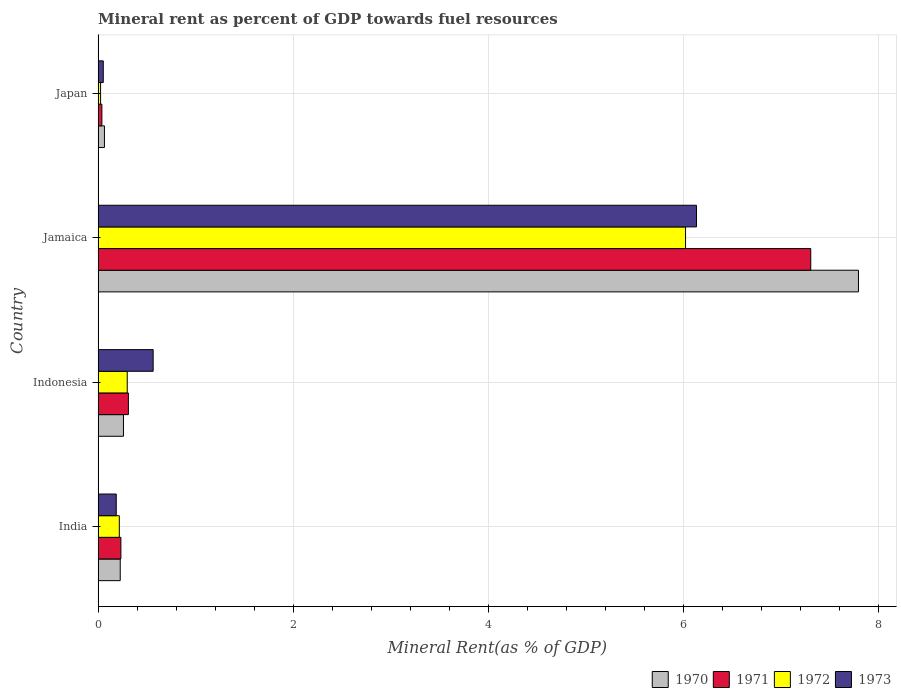How many groups of bars are there?
Your response must be concise. 4. How many bars are there on the 4th tick from the top?
Make the answer very short. 4. How many bars are there on the 2nd tick from the bottom?
Give a very brief answer. 4. In how many cases, is the number of bars for a given country not equal to the number of legend labels?
Keep it short and to the point. 0. What is the mineral rent in 1973 in Japan?
Give a very brief answer. 0.05. Across all countries, what is the maximum mineral rent in 1972?
Give a very brief answer. 6.03. Across all countries, what is the minimum mineral rent in 1971?
Your answer should be very brief. 0.04. In which country was the mineral rent in 1973 maximum?
Offer a terse response. Jamaica. In which country was the mineral rent in 1972 minimum?
Offer a very short reply. Japan. What is the total mineral rent in 1970 in the graph?
Provide a succinct answer. 8.35. What is the difference between the mineral rent in 1972 in Indonesia and that in Japan?
Ensure brevity in your answer.  0.27. What is the difference between the mineral rent in 1973 in India and the mineral rent in 1970 in Indonesia?
Keep it short and to the point. -0.07. What is the average mineral rent in 1970 per country?
Your response must be concise. 2.09. What is the difference between the mineral rent in 1973 and mineral rent in 1972 in Japan?
Offer a very short reply. 0.03. In how many countries, is the mineral rent in 1971 greater than 6.4 %?
Make the answer very short. 1. What is the ratio of the mineral rent in 1970 in India to that in Jamaica?
Provide a short and direct response. 0.03. What is the difference between the highest and the second highest mineral rent in 1970?
Your answer should be compact. 7.54. What is the difference between the highest and the lowest mineral rent in 1971?
Provide a short and direct response. 7.27. Is the sum of the mineral rent in 1973 in India and Indonesia greater than the maximum mineral rent in 1972 across all countries?
Keep it short and to the point. No. Is it the case that in every country, the sum of the mineral rent in 1970 and mineral rent in 1973 is greater than the mineral rent in 1971?
Ensure brevity in your answer.  Yes. How many bars are there?
Your answer should be very brief. 16. Are all the bars in the graph horizontal?
Give a very brief answer. Yes. Does the graph contain any zero values?
Offer a terse response. No. Does the graph contain grids?
Provide a short and direct response. Yes. Where does the legend appear in the graph?
Ensure brevity in your answer.  Bottom right. How many legend labels are there?
Make the answer very short. 4. How are the legend labels stacked?
Make the answer very short. Horizontal. What is the title of the graph?
Your answer should be very brief. Mineral rent as percent of GDP towards fuel resources. What is the label or title of the X-axis?
Make the answer very short. Mineral Rent(as % of GDP). What is the Mineral Rent(as % of GDP) of 1970 in India?
Provide a succinct answer. 0.23. What is the Mineral Rent(as % of GDP) of 1971 in India?
Offer a very short reply. 0.23. What is the Mineral Rent(as % of GDP) in 1972 in India?
Your response must be concise. 0.22. What is the Mineral Rent(as % of GDP) of 1973 in India?
Provide a short and direct response. 0.19. What is the Mineral Rent(as % of GDP) of 1970 in Indonesia?
Your answer should be very brief. 0.26. What is the Mineral Rent(as % of GDP) in 1971 in Indonesia?
Your answer should be compact. 0.31. What is the Mineral Rent(as % of GDP) in 1972 in Indonesia?
Ensure brevity in your answer.  0.3. What is the Mineral Rent(as % of GDP) of 1973 in Indonesia?
Provide a short and direct response. 0.56. What is the Mineral Rent(as % of GDP) in 1970 in Jamaica?
Give a very brief answer. 7.8. What is the Mineral Rent(as % of GDP) of 1971 in Jamaica?
Provide a short and direct response. 7.31. What is the Mineral Rent(as % of GDP) of 1972 in Jamaica?
Make the answer very short. 6.03. What is the Mineral Rent(as % of GDP) of 1973 in Jamaica?
Offer a very short reply. 6.14. What is the Mineral Rent(as % of GDP) in 1970 in Japan?
Make the answer very short. 0.06. What is the Mineral Rent(as % of GDP) in 1971 in Japan?
Provide a short and direct response. 0.04. What is the Mineral Rent(as % of GDP) in 1972 in Japan?
Provide a short and direct response. 0.03. What is the Mineral Rent(as % of GDP) of 1973 in Japan?
Offer a terse response. 0.05. Across all countries, what is the maximum Mineral Rent(as % of GDP) of 1970?
Offer a very short reply. 7.8. Across all countries, what is the maximum Mineral Rent(as % of GDP) in 1971?
Your response must be concise. 7.31. Across all countries, what is the maximum Mineral Rent(as % of GDP) of 1972?
Provide a short and direct response. 6.03. Across all countries, what is the maximum Mineral Rent(as % of GDP) in 1973?
Ensure brevity in your answer.  6.14. Across all countries, what is the minimum Mineral Rent(as % of GDP) in 1970?
Your answer should be compact. 0.06. Across all countries, what is the minimum Mineral Rent(as % of GDP) of 1971?
Provide a succinct answer. 0.04. Across all countries, what is the minimum Mineral Rent(as % of GDP) of 1972?
Give a very brief answer. 0.03. Across all countries, what is the minimum Mineral Rent(as % of GDP) in 1973?
Your response must be concise. 0.05. What is the total Mineral Rent(as % of GDP) in 1970 in the graph?
Make the answer very short. 8.35. What is the total Mineral Rent(as % of GDP) in 1971 in the graph?
Keep it short and to the point. 7.89. What is the total Mineral Rent(as % of GDP) of 1972 in the graph?
Make the answer very short. 6.57. What is the total Mineral Rent(as % of GDP) of 1973 in the graph?
Provide a short and direct response. 6.94. What is the difference between the Mineral Rent(as % of GDP) in 1970 in India and that in Indonesia?
Your response must be concise. -0.03. What is the difference between the Mineral Rent(as % of GDP) in 1971 in India and that in Indonesia?
Your response must be concise. -0.08. What is the difference between the Mineral Rent(as % of GDP) of 1972 in India and that in Indonesia?
Your answer should be very brief. -0.08. What is the difference between the Mineral Rent(as % of GDP) in 1973 in India and that in Indonesia?
Your answer should be compact. -0.38. What is the difference between the Mineral Rent(as % of GDP) in 1970 in India and that in Jamaica?
Provide a succinct answer. -7.57. What is the difference between the Mineral Rent(as % of GDP) of 1971 in India and that in Jamaica?
Your answer should be very brief. -7.08. What is the difference between the Mineral Rent(as % of GDP) of 1972 in India and that in Jamaica?
Keep it short and to the point. -5.81. What is the difference between the Mineral Rent(as % of GDP) of 1973 in India and that in Jamaica?
Provide a short and direct response. -5.95. What is the difference between the Mineral Rent(as % of GDP) in 1970 in India and that in Japan?
Provide a succinct answer. 0.16. What is the difference between the Mineral Rent(as % of GDP) in 1971 in India and that in Japan?
Provide a short and direct response. 0.2. What is the difference between the Mineral Rent(as % of GDP) in 1972 in India and that in Japan?
Your answer should be very brief. 0.19. What is the difference between the Mineral Rent(as % of GDP) in 1973 in India and that in Japan?
Give a very brief answer. 0.13. What is the difference between the Mineral Rent(as % of GDP) of 1970 in Indonesia and that in Jamaica?
Keep it short and to the point. -7.54. What is the difference between the Mineral Rent(as % of GDP) of 1971 in Indonesia and that in Jamaica?
Your response must be concise. -7. What is the difference between the Mineral Rent(as % of GDP) of 1972 in Indonesia and that in Jamaica?
Offer a very short reply. -5.73. What is the difference between the Mineral Rent(as % of GDP) of 1973 in Indonesia and that in Jamaica?
Offer a terse response. -5.57. What is the difference between the Mineral Rent(as % of GDP) of 1970 in Indonesia and that in Japan?
Offer a very short reply. 0.2. What is the difference between the Mineral Rent(as % of GDP) of 1971 in Indonesia and that in Japan?
Provide a succinct answer. 0.27. What is the difference between the Mineral Rent(as % of GDP) in 1972 in Indonesia and that in Japan?
Provide a short and direct response. 0.27. What is the difference between the Mineral Rent(as % of GDP) of 1973 in Indonesia and that in Japan?
Keep it short and to the point. 0.51. What is the difference between the Mineral Rent(as % of GDP) in 1970 in Jamaica and that in Japan?
Keep it short and to the point. 7.73. What is the difference between the Mineral Rent(as % of GDP) of 1971 in Jamaica and that in Japan?
Ensure brevity in your answer.  7.27. What is the difference between the Mineral Rent(as % of GDP) in 1972 in Jamaica and that in Japan?
Provide a succinct answer. 6. What is the difference between the Mineral Rent(as % of GDP) in 1973 in Jamaica and that in Japan?
Your answer should be very brief. 6.08. What is the difference between the Mineral Rent(as % of GDP) in 1970 in India and the Mineral Rent(as % of GDP) in 1971 in Indonesia?
Offer a terse response. -0.08. What is the difference between the Mineral Rent(as % of GDP) of 1970 in India and the Mineral Rent(as % of GDP) of 1972 in Indonesia?
Provide a succinct answer. -0.07. What is the difference between the Mineral Rent(as % of GDP) of 1970 in India and the Mineral Rent(as % of GDP) of 1973 in Indonesia?
Provide a succinct answer. -0.34. What is the difference between the Mineral Rent(as % of GDP) of 1971 in India and the Mineral Rent(as % of GDP) of 1972 in Indonesia?
Provide a succinct answer. -0.07. What is the difference between the Mineral Rent(as % of GDP) in 1971 in India and the Mineral Rent(as % of GDP) in 1973 in Indonesia?
Provide a succinct answer. -0.33. What is the difference between the Mineral Rent(as % of GDP) of 1972 in India and the Mineral Rent(as % of GDP) of 1973 in Indonesia?
Ensure brevity in your answer.  -0.35. What is the difference between the Mineral Rent(as % of GDP) in 1970 in India and the Mineral Rent(as % of GDP) in 1971 in Jamaica?
Keep it short and to the point. -7.08. What is the difference between the Mineral Rent(as % of GDP) of 1970 in India and the Mineral Rent(as % of GDP) of 1972 in Jamaica?
Keep it short and to the point. -5.8. What is the difference between the Mineral Rent(as % of GDP) of 1970 in India and the Mineral Rent(as % of GDP) of 1973 in Jamaica?
Offer a terse response. -5.91. What is the difference between the Mineral Rent(as % of GDP) in 1971 in India and the Mineral Rent(as % of GDP) in 1972 in Jamaica?
Offer a very short reply. -5.79. What is the difference between the Mineral Rent(as % of GDP) in 1971 in India and the Mineral Rent(as % of GDP) in 1973 in Jamaica?
Provide a short and direct response. -5.9. What is the difference between the Mineral Rent(as % of GDP) of 1972 in India and the Mineral Rent(as % of GDP) of 1973 in Jamaica?
Offer a terse response. -5.92. What is the difference between the Mineral Rent(as % of GDP) of 1970 in India and the Mineral Rent(as % of GDP) of 1971 in Japan?
Your answer should be very brief. 0.19. What is the difference between the Mineral Rent(as % of GDP) in 1970 in India and the Mineral Rent(as % of GDP) in 1972 in Japan?
Your answer should be compact. 0.2. What is the difference between the Mineral Rent(as % of GDP) in 1970 in India and the Mineral Rent(as % of GDP) in 1973 in Japan?
Provide a short and direct response. 0.17. What is the difference between the Mineral Rent(as % of GDP) in 1971 in India and the Mineral Rent(as % of GDP) in 1972 in Japan?
Ensure brevity in your answer.  0.21. What is the difference between the Mineral Rent(as % of GDP) in 1971 in India and the Mineral Rent(as % of GDP) in 1973 in Japan?
Ensure brevity in your answer.  0.18. What is the difference between the Mineral Rent(as % of GDP) in 1972 in India and the Mineral Rent(as % of GDP) in 1973 in Japan?
Offer a very short reply. 0.16. What is the difference between the Mineral Rent(as % of GDP) in 1970 in Indonesia and the Mineral Rent(as % of GDP) in 1971 in Jamaica?
Keep it short and to the point. -7.05. What is the difference between the Mineral Rent(as % of GDP) in 1970 in Indonesia and the Mineral Rent(as % of GDP) in 1972 in Jamaica?
Offer a very short reply. -5.77. What is the difference between the Mineral Rent(as % of GDP) in 1970 in Indonesia and the Mineral Rent(as % of GDP) in 1973 in Jamaica?
Provide a succinct answer. -5.88. What is the difference between the Mineral Rent(as % of GDP) in 1971 in Indonesia and the Mineral Rent(as % of GDP) in 1972 in Jamaica?
Offer a very short reply. -5.72. What is the difference between the Mineral Rent(as % of GDP) of 1971 in Indonesia and the Mineral Rent(as % of GDP) of 1973 in Jamaica?
Offer a very short reply. -5.83. What is the difference between the Mineral Rent(as % of GDP) in 1972 in Indonesia and the Mineral Rent(as % of GDP) in 1973 in Jamaica?
Make the answer very short. -5.84. What is the difference between the Mineral Rent(as % of GDP) of 1970 in Indonesia and the Mineral Rent(as % of GDP) of 1971 in Japan?
Your answer should be very brief. 0.22. What is the difference between the Mineral Rent(as % of GDP) of 1970 in Indonesia and the Mineral Rent(as % of GDP) of 1972 in Japan?
Your answer should be very brief. 0.23. What is the difference between the Mineral Rent(as % of GDP) of 1970 in Indonesia and the Mineral Rent(as % of GDP) of 1973 in Japan?
Provide a short and direct response. 0.21. What is the difference between the Mineral Rent(as % of GDP) in 1971 in Indonesia and the Mineral Rent(as % of GDP) in 1972 in Japan?
Give a very brief answer. 0.29. What is the difference between the Mineral Rent(as % of GDP) of 1971 in Indonesia and the Mineral Rent(as % of GDP) of 1973 in Japan?
Offer a very short reply. 0.26. What is the difference between the Mineral Rent(as % of GDP) of 1972 in Indonesia and the Mineral Rent(as % of GDP) of 1973 in Japan?
Ensure brevity in your answer.  0.25. What is the difference between the Mineral Rent(as % of GDP) in 1970 in Jamaica and the Mineral Rent(as % of GDP) in 1971 in Japan?
Your response must be concise. 7.76. What is the difference between the Mineral Rent(as % of GDP) in 1970 in Jamaica and the Mineral Rent(as % of GDP) in 1972 in Japan?
Offer a terse response. 7.77. What is the difference between the Mineral Rent(as % of GDP) of 1970 in Jamaica and the Mineral Rent(as % of GDP) of 1973 in Japan?
Offer a very short reply. 7.75. What is the difference between the Mineral Rent(as % of GDP) of 1971 in Jamaica and the Mineral Rent(as % of GDP) of 1972 in Japan?
Offer a terse response. 7.28. What is the difference between the Mineral Rent(as % of GDP) of 1971 in Jamaica and the Mineral Rent(as % of GDP) of 1973 in Japan?
Offer a terse response. 7.26. What is the difference between the Mineral Rent(as % of GDP) in 1972 in Jamaica and the Mineral Rent(as % of GDP) in 1973 in Japan?
Give a very brief answer. 5.97. What is the average Mineral Rent(as % of GDP) of 1970 per country?
Your answer should be very brief. 2.09. What is the average Mineral Rent(as % of GDP) of 1971 per country?
Keep it short and to the point. 1.97. What is the average Mineral Rent(as % of GDP) in 1972 per country?
Give a very brief answer. 1.64. What is the average Mineral Rent(as % of GDP) in 1973 per country?
Your answer should be compact. 1.74. What is the difference between the Mineral Rent(as % of GDP) in 1970 and Mineral Rent(as % of GDP) in 1971 in India?
Your answer should be compact. -0.01. What is the difference between the Mineral Rent(as % of GDP) of 1970 and Mineral Rent(as % of GDP) of 1972 in India?
Keep it short and to the point. 0.01. What is the difference between the Mineral Rent(as % of GDP) of 1970 and Mineral Rent(as % of GDP) of 1973 in India?
Make the answer very short. 0.04. What is the difference between the Mineral Rent(as % of GDP) in 1971 and Mineral Rent(as % of GDP) in 1972 in India?
Keep it short and to the point. 0.02. What is the difference between the Mineral Rent(as % of GDP) of 1971 and Mineral Rent(as % of GDP) of 1973 in India?
Provide a short and direct response. 0.05. What is the difference between the Mineral Rent(as % of GDP) in 1972 and Mineral Rent(as % of GDP) in 1973 in India?
Offer a very short reply. 0.03. What is the difference between the Mineral Rent(as % of GDP) in 1970 and Mineral Rent(as % of GDP) in 1971 in Indonesia?
Offer a terse response. -0.05. What is the difference between the Mineral Rent(as % of GDP) in 1970 and Mineral Rent(as % of GDP) in 1972 in Indonesia?
Your answer should be compact. -0.04. What is the difference between the Mineral Rent(as % of GDP) of 1970 and Mineral Rent(as % of GDP) of 1973 in Indonesia?
Offer a terse response. -0.3. What is the difference between the Mineral Rent(as % of GDP) of 1971 and Mineral Rent(as % of GDP) of 1972 in Indonesia?
Your answer should be compact. 0.01. What is the difference between the Mineral Rent(as % of GDP) in 1971 and Mineral Rent(as % of GDP) in 1973 in Indonesia?
Keep it short and to the point. -0.25. What is the difference between the Mineral Rent(as % of GDP) in 1972 and Mineral Rent(as % of GDP) in 1973 in Indonesia?
Give a very brief answer. -0.27. What is the difference between the Mineral Rent(as % of GDP) in 1970 and Mineral Rent(as % of GDP) in 1971 in Jamaica?
Keep it short and to the point. 0.49. What is the difference between the Mineral Rent(as % of GDP) of 1970 and Mineral Rent(as % of GDP) of 1972 in Jamaica?
Provide a succinct answer. 1.77. What is the difference between the Mineral Rent(as % of GDP) in 1970 and Mineral Rent(as % of GDP) in 1973 in Jamaica?
Your answer should be compact. 1.66. What is the difference between the Mineral Rent(as % of GDP) of 1971 and Mineral Rent(as % of GDP) of 1972 in Jamaica?
Offer a very short reply. 1.28. What is the difference between the Mineral Rent(as % of GDP) of 1971 and Mineral Rent(as % of GDP) of 1973 in Jamaica?
Your response must be concise. 1.17. What is the difference between the Mineral Rent(as % of GDP) in 1972 and Mineral Rent(as % of GDP) in 1973 in Jamaica?
Ensure brevity in your answer.  -0.11. What is the difference between the Mineral Rent(as % of GDP) of 1970 and Mineral Rent(as % of GDP) of 1971 in Japan?
Provide a succinct answer. 0.03. What is the difference between the Mineral Rent(as % of GDP) of 1970 and Mineral Rent(as % of GDP) of 1972 in Japan?
Offer a terse response. 0.04. What is the difference between the Mineral Rent(as % of GDP) in 1970 and Mineral Rent(as % of GDP) in 1973 in Japan?
Offer a very short reply. 0.01. What is the difference between the Mineral Rent(as % of GDP) of 1971 and Mineral Rent(as % of GDP) of 1972 in Japan?
Provide a short and direct response. 0.01. What is the difference between the Mineral Rent(as % of GDP) of 1971 and Mineral Rent(as % of GDP) of 1973 in Japan?
Offer a very short reply. -0.01. What is the difference between the Mineral Rent(as % of GDP) in 1972 and Mineral Rent(as % of GDP) in 1973 in Japan?
Your answer should be compact. -0.03. What is the ratio of the Mineral Rent(as % of GDP) of 1970 in India to that in Indonesia?
Offer a terse response. 0.87. What is the ratio of the Mineral Rent(as % of GDP) of 1971 in India to that in Indonesia?
Make the answer very short. 0.75. What is the ratio of the Mineral Rent(as % of GDP) in 1972 in India to that in Indonesia?
Keep it short and to the point. 0.73. What is the ratio of the Mineral Rent(as % of GDP) in 1973 in India to that in Indonesia?
Ensure brevity in your answer.  0.33. What is the ratio of the Mineral Rent(as % of GDP) of 1970 in India to that in Jamaica?
Ensure brevity in your answer.  0.03. What is the ratio of the Mineral Rent(as % of GDP) in 1971 in India to that in Jamaica?
Offer a very short reply. 0.03. What is the ratio of the Mineral Rent(as % of GDP) of 1972 in India to that in Jamaica?
Give a very brief answer. 0.04. What is the ratio of the Mineral Rent(as % of GDP) of 1973 in India to that in Jamaica?
Give a very brief answer. 0.03. What is the ratio of the Mineral Rent(as % of GDP) in 1970 in India to that in Japan?
Your answer should be very brief. 3.5. What is the ratio of the Mineral Rent(as % of GDP) of 1971 in India to that in Japan?
Give a very brief answer. 6.06. What is the ratio of the Mineral Rent(as % of GDP) in 1972 in India to that in Japan?
Provide a short and direct response. 8.6. What is the ratio of the Mineral Rent(as % of GDP) of 1973 in India to that in Japan?
Your answer should be compact. 3.52. What is the ratio of the Mineral Rent(as % of GDP) of 1970 in Indonesia to that in Jamaica?
Offer a very short reply. 0.03. What is the ratio of the Mineral Rent(as % of GDP) of 1971 in Indonesia to that in Jamaica?
Offer a terse response. 0.04. What is the ratio of the Mineral Rent(as % of GDP) of 1972 in Indonesia to that in Jamaica?
Your answer should be compact. 0.05. What is the ratio of the Mineral Rent(as % of GDP) of 1973 in Indonesia to that in Jamaica?
Provide a succinct answer. 0.09. What is the ratio of the Mineral Rent(as % of GDP) in 1970 in Indonesia to that in Japan?
Your answer should be compact. 4.01. What is the ratio of the Mineral Rent(as % of GDP) of 1971 in Indonesia to that in Japan?
Your response must be concise. 8.06. What is the ratio of the Mineral Rent(as % of GDP) in 1972 in Indonesia to that in Japan?
Ensure brevity in your answer.  11.82. What is the ratio of the Mineral Rent(as % of GDP) in 1973 in Indonesia to that in Japan?
Ensure brevity in your answer.  10.69. What is the ratio of the Mineral Rent(as % of GDP) of 1970 in Jamaica to that in Japan?
Keep it short and to the point. 120.23. What is the ratio of the Mineral Rent(as % of GDP) of 1971 in Jamaica to that in Japan?
Keep it short and to the point. 189.73. What is the ratio of the Mineral Rent(as % of GDP) in 1972 in Jamaica to that in Japan?
Make the answer very short. 238.51. What is the ratio of the Mineral Rent(as % of GDP) of 1973 in Jamaica to that in Japan?
Offer a terse response. 116.18. What is the difference between the highest and the second highest Mineral Rent(as % of GDP) of 1970?
Give a very brief answer. 7.54. What is the difference between the highest and the second highest Mineral Rent(as % of GDP) of 1971?
Your answer should be very brief. 7. What is the difference between the highest and the second highest Mineral Rent(as % of GDP) in 1972?
Offer a very short reply. 5.73. What is the difference between the highest and the second highest Mineral Rent(as % of GDP) in 1973?
Give a very brief answer. 5.57. What is the difference between the highest and the lowest Mineral Rent(as % of GDP) in 1970?
Your response must be concise. 7.73. What is the difference between the highest and the lowest Mineral Rent(as % of GDP) of 1971?
Provide a succinct answer. 7.27. What is the difference between the highest and the lowest Mineral Rent(as % of GDP) in 1972?
Ensure brevity in your answer.  6. What is the difference between the highest and the lowest Mineral Rent(as % of GDP) in 1973?
Offer a terse response. 6.08. 